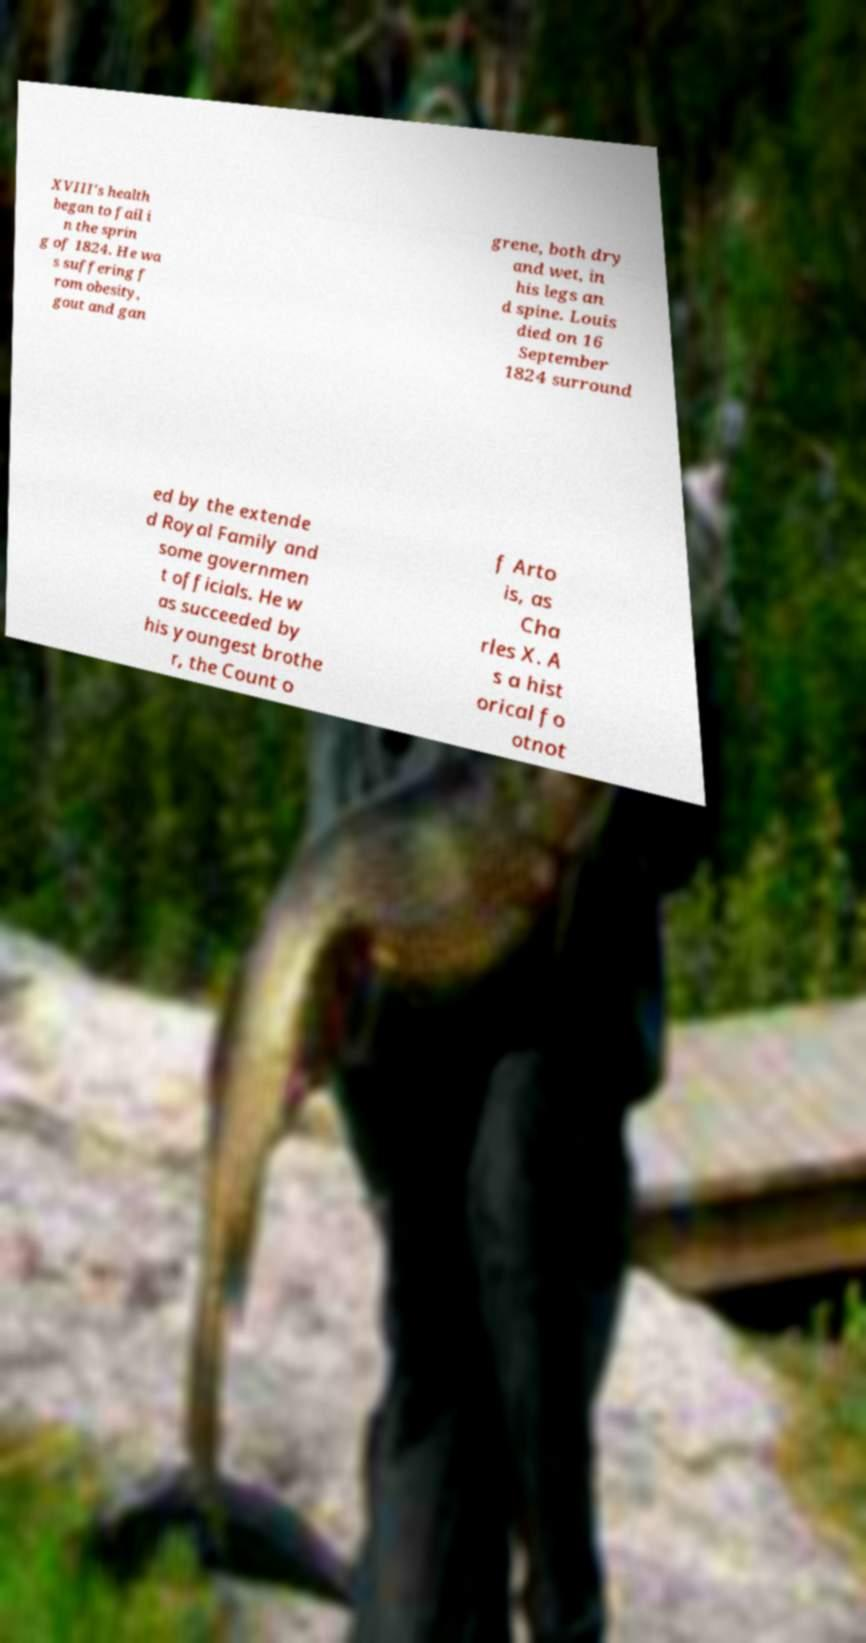Can you read and provide the text displayed in the image?This photo seems to have some interesting text. Can you extract and type it out for me? XVIII's health began to fail i n the sprin g of 1824. He wa s suffering f rom obesity, gout and gan grene, both dry and wet, in his legs an d spine. Louis died on 16 September 1824 surround ed by the extende d Royal Family and some governmen t officials. He w as succeeded by his youngest brothe r, the Count o f Arto is, as Cha rles X. A s a hist orical fo otnot 